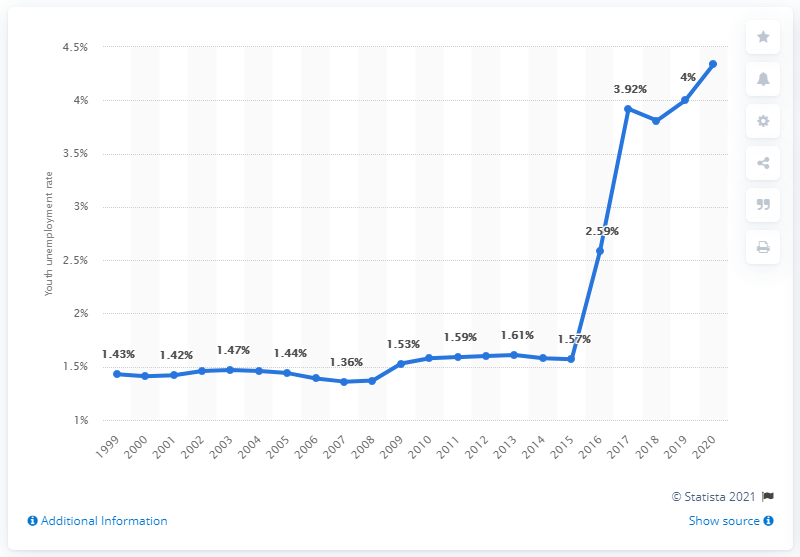Outline some significant characteristics in this image. In 2020, the youth unemployment rate in Burma was 4.34%. 